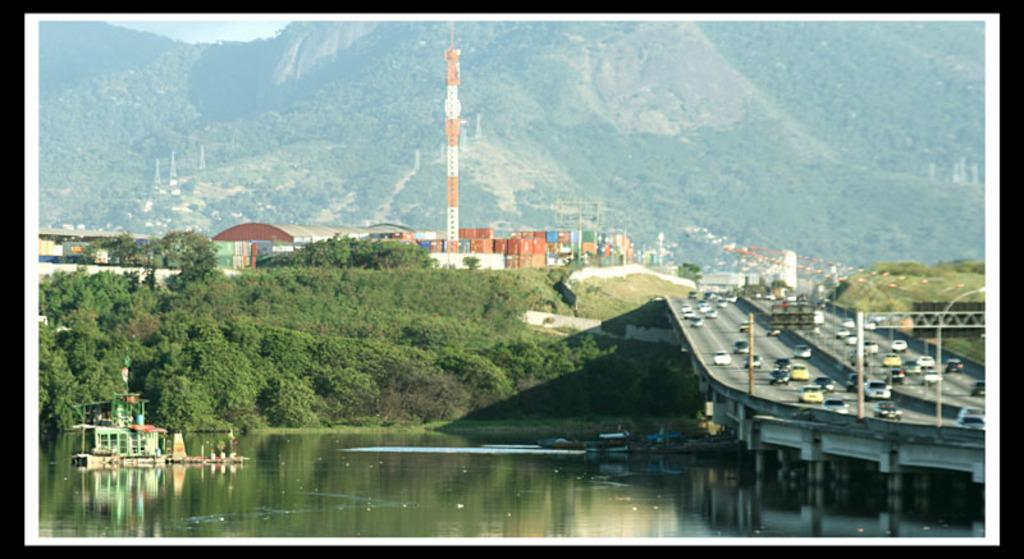What type of natural formation can be seen in the image? There are mountains in the image. What type of vegetation is present in the image? There are trees in the image. What type of structure is visible in the image? There is a tower in the image. What type of objects are present in the image that might be used for storage or transportation? There are containers and vehicles visible in the image. What type of man-made objects are present in the image that might be used for support or signaling? There are poles in the image. What type of transportation is visible in the image that is not on land? There are boats in the image. What type of colorful object can be seen floating on the water? There is a colorful object on the water in the image. What type of advice does the writer give to the grandfather in the image? There is no writer or grandfather present in the image, so it is not possible to answer that question. What type of machine is used to create the colorful object on the water? There is no machine involved in creating the colorful object on the water in the image. 